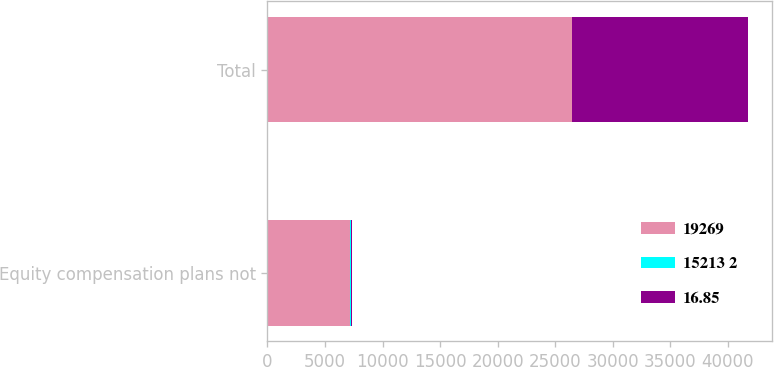Convert chart. <chart><loc_0><loc_0><loc_500><loc_500><stacked_bar_chart><ecel><fcel>Equity compensation plans not<fcel>Total<nl><fcel>19269<fcel>7199<fcel>26468<nl><fcel>15213 2<fcel>16.66<fcel>16.8<nl><fcel>16.85<fcel>109<fcel>15322<nl></chart> 